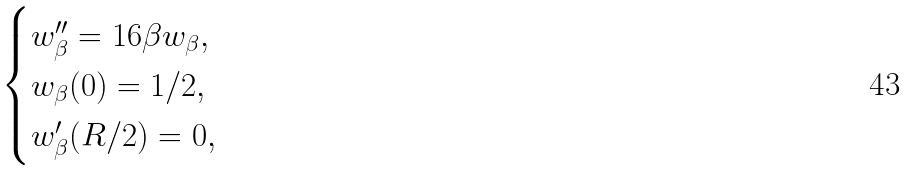Convert formula to latex. <formula><loc_0><loc_0><loc_500><loc_500>\begin{cases} w _ { \beta } ^ { \prime \prime } = 1 6 \beta w _ { \beta } , \\ w _ { \beta } ( 0 ) = 1 / { 2 } , \\ w _ { \beta } ^ { \prime } ( { R } / { 2 } ) = 0 , \end{cases}</formula> 